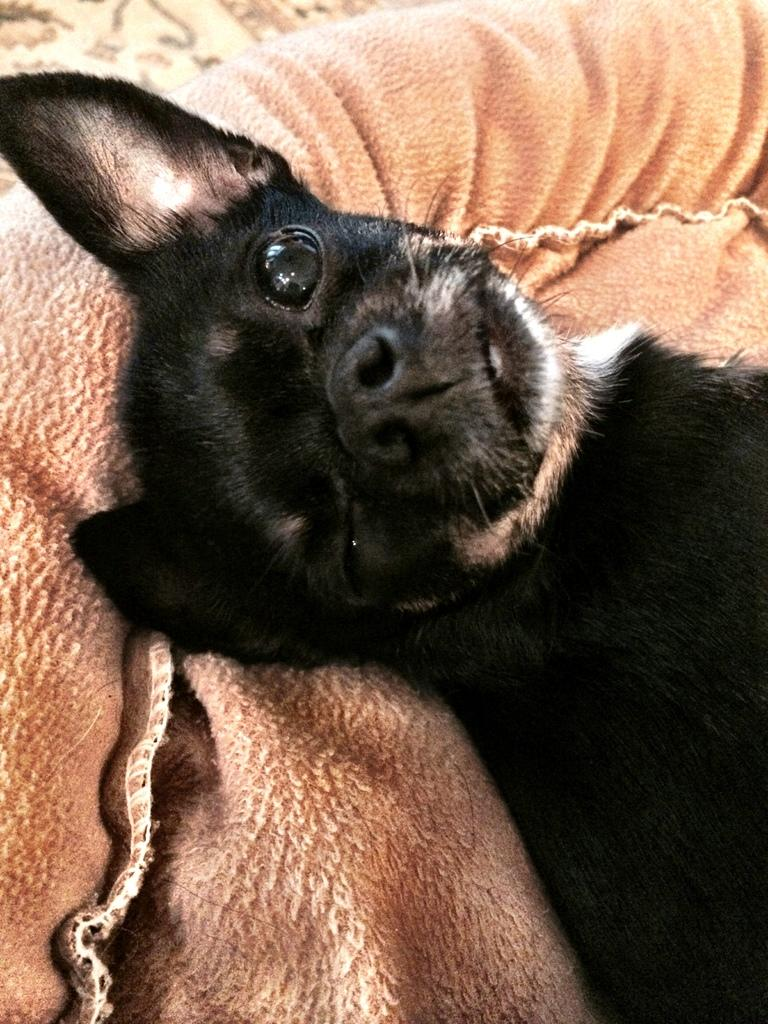What type of animal can be seen in the image? There is a black color animal in the image. Where is the animal located in the image? The animal is in the middle of the image. What can be seen in the background of the image? There is a cloth visible in the background of the image. How does the animal contribute to the increase of dirt in the image? The animal does not contribute to the increase of dirt in the image, as there is no indication of dirt or any action that would cause dirt to accumulate. 